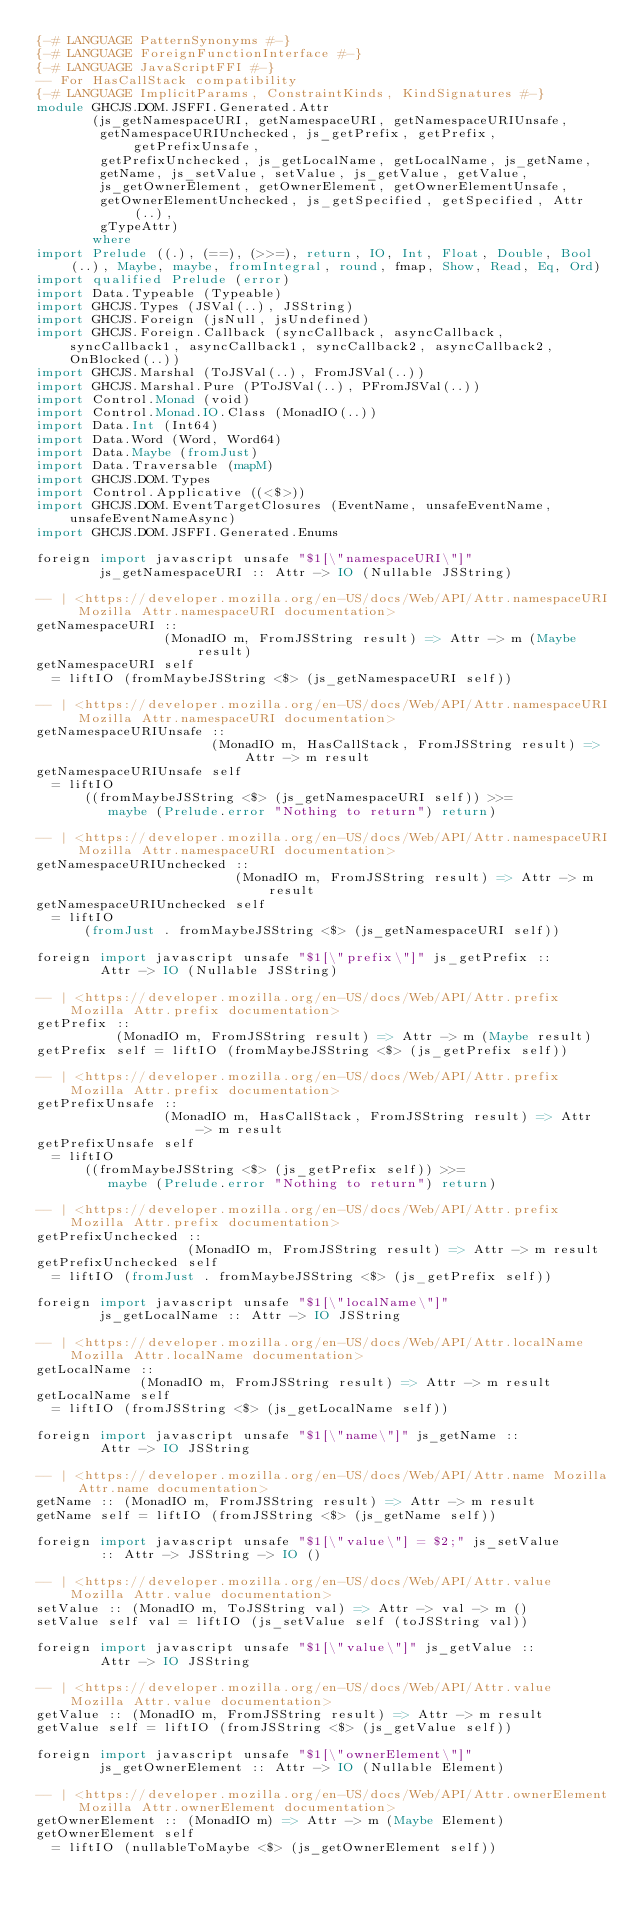<code> <loc_0><loc_0><loc_500><loc_500><_Haskell_>{-# LANGUAGE PatternSynonyms #-}
{-# LANGUAGE ForeignFunctionInterface #-}
{-# LANGUAGE JavaScriptFFI #-}
-- For HasCallStack compatibility
{-# LANGUAGE ImplicitParams, ConstraintKinds, KindSignatures #-}
module GHCJS.DOM.JSFFI.Generated.Attr
       (js_getNamespaceURI, getNamespaceURI, getNamespaceURIUnsafe,
        getNamespaceURIUnchecked, js_getPrefix, getPrefix, getPrefixUnsafe,
        getPrefixUnchecked, js_getLocalName, getLocalName, js_getName,
        getName, js_setValue, setValue, js_getValue, getValue,
        js_getOwnerElement, getOwnerElement, getOwnerElementUnsafe,
        getOwnerElementUnchecked, js_getSpecified, getSpecified, Attr(..),
        gTypeAttr)
       where
import Prelude ((.), (==), (>>=), return, IO, Int, Float, Double, Bool(..), Maybe, maybe, fromIntegral, round, fmap, Show, Read, Eq, Ord)
import qualified Prelude (error)
import Data.Typeable (Typeable)
import GHCJS.Types (JSVal(..), JSString)
import GHCJS.Foreign (jsNull, jsUndefined)
import GHCJS.Foreign.Callback (syncCallback, asyncCallback, syncCallback1, asyncCallback1, syncCallback2, asyncCallback2, OnBlocked(..))
import GHCJS.Marshal (ToJSVal(..), FromJSVal(..))
import GHCJS.Marshal.Pure (PToJSVal(..), PFromJSVal(..))
import Control.Monad (void)
import Control.Monad.IO.Class (MonadIO(..))
import Data.Int (Int64)
import Data.Word (Word, Word64)
import Data.Maybe (fromJust)
import Data.Traversable (mapM)
import GHCJS.DOM.Types
import Control.Applicative ((<$>))
import GHCJS.DOM.EventTargetClosures (EventName, unsafeEventName, unsafeEventNameAsync)
import GHCJS.DOM.JSFFI.Generated.Enums
 
foreign import javascript unsafe "$1[\"namespaceURI\"]"
        js_getNamespaceURI :: Attr -> IO (Nullable JSString)

-- | <https://developer.mozilla.org/en-US/docs/Web/API/Attr.namespaceURI Mozilla Attr.namespaceURI documentation> 
getNamespaceURI ::
                (MonadIO m, FromJSString result) => Attr -> m (Maybe result)
getNamespaceURI self
  = liftIO (fromMaybeJSString <$> (js_getNamespaceURI self))

-- | <https://developer.mozilla.org/en-US/docs/Web/API/Attr.namespaceURI Mozilla Attr.namespaceURI documentation> 
getNamespaceURIUnsafe ::
                      (MonadIO m, HasCallStack, FromJSString result) => Attr -> m result
getNamespaceURIUnsafe self
  = liftIO
      ((fromMaybeJSString <$> (js_getNamespaceURI self)) >>=
         maybe (Prelude.error "Nothing to return") return)

-- | <https://developer.mozilla.org/en-US/docs/Web/API/Attr.namespaceURI Mozilla Attr.namespaceURI documentation> 
getNamespaceURIUnchecked ::
                         (MonadIO m, FromJSString result) => Attr -> m result
getNamespaceURIUnchecked self
  = liftIO
      (fromJust . fromMaybeJSString <$> (js_getNamespaceURI self))
 
foreign import javascript unsafe "$1[\"prefix\"]" js_getPrefix ::
        Attr -> IO (Nullable JSString)

-- | <https://developer.mozilla.org/en-US/docs/Web/API/Attr.prefix Mozilla Attr.prefix documentation> 
getPrefix ::
          (MonadIO m, FromJSString result) => Attr -> m (Maybe result)
getPrefix self = liftIO (fromMaybeJSString <$> (js_getPrefix self))

-- | <https://developer.mozilla.org/en-US/docs/Web/API/Attr.prefix Mozilla Attr.prefix documentation> 
getPrefixUnsafe ::
                (MonadIO m, HasCallStack, FromJSString result) => Attr -> m result
getPrefixUnsafe self
  = liftIO
      ((fromMaybeJSString <$> (js_getPrefix self)) >>=
         maybe (Prelude.error "Nothing to return") return)

-- | <https://developer.mozilla.org/en-US/docs/Web/API/Attr.prefix Mozilla Attr.prefix documentation> 
getPrefixUnchecked ::
                   (MonadIO m, FromJSString result) => Attr -> m result
getPrefixUnchecked self
  = liftIO (fromJust . fromMaybeJSString <$> (js_getPrefix self))
 
foreign import javascript unsafe "$1[\"localName\"]"
        js_getLocalName :: Attr -> IO JSString

-- | <https://developer.mozilla.org/en-US/docs/Web/API/Attr.localName Mozilla Attr.localName documentation> 
getLocalName ::
             (MonadIO m, FromJSString result) => Attr -> m result
getLocalName self
  = liftIO (fromJSString <$> (js_getLocalName self))
 
foreign import javascript unsafe "$1[\"name\"]" js_getName ::
        Attr -> IO JSString

-- | <https://developer.mozilla.org/en-US/docs/Web/API/Attr.name Mozilla Attr.name documentation> 
getName :: (MonadIO m, FromJSString result) => Attr -> m result
getName self = liftIO (fromJSString <$> (js_getName self))
 
foreign import javascript unsafe "$1[\"value\"] = $2;" js_setValue
        :: Attr -> JSString -> IO ()

-- | <https://developer.mozilla.org/en-US/docs/Web/API/Attr.value Mozilla Attr.value documentation> 
setValue :: (MonadIO m, ToJSString val) => Attr -> val -> m ()
setValue self val = liftIO (js_setValue self (toJSString val))
 
foreign import javascript unsafe "$1[\"value\"]" js_getValue ::
        Attr -> IO JSString

-- | <https://developer.mozilla.org/en-US/docs/Web/API/Attr.value Mozilla Attr.value documentation> 
getValue :: (MonadIO m, FromJSString result) => Attr -> m result
getValue self = liftIO (fromJSString <$> (js_getValue self))
 
foreign import javascript unsafe "$1[\"ownerElement\"]"
        js_getOwnerElement :: Attr -> IO (Nullable Element)

-- | <https://developer.mozilla.org/en-US/docs/Web/API/Attr.ownerElement Mozilla Attr.ownerElement documentation> 
getOwnerElement :: (MonadIO m) => Attr -> m (Maybe Element)
getOwnerElement self
  = liftIO (nullableToMaybe <$> (js_getOwnerElement self))
</code> 